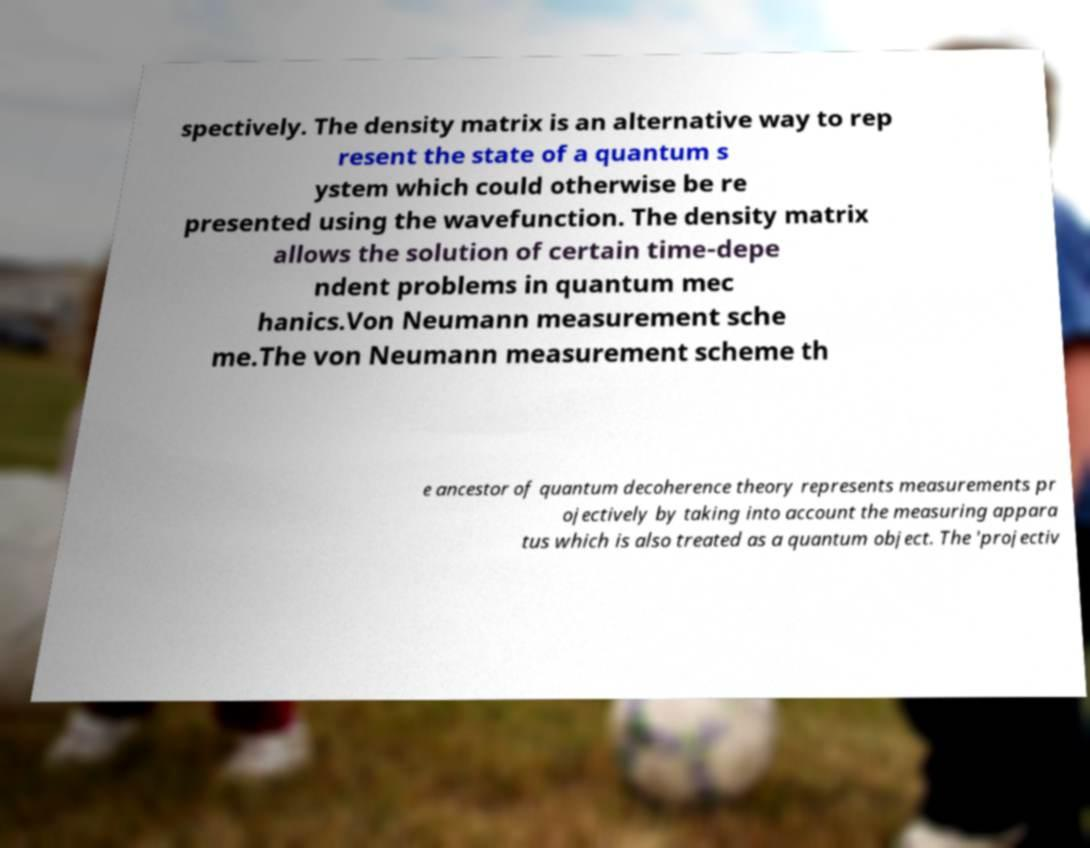What messages or text are displayed in this image? I need them in a readable, typed format. spectively. The density matrix is an alternative way to rep resent the state of a quantum s ystem which could otherwise be re presented using the wavefunction. The density matrix allows the solution of certain time-depe ndent problems in quantum mec hanics.Von Neumann measurement sche me.The von Neumann measurement scheme th e ancestor of quantum decoherence theory represents measurements pr ojectively by taking into account the measuring appara tus which is also treated as a quantum object. The 'projectiv 